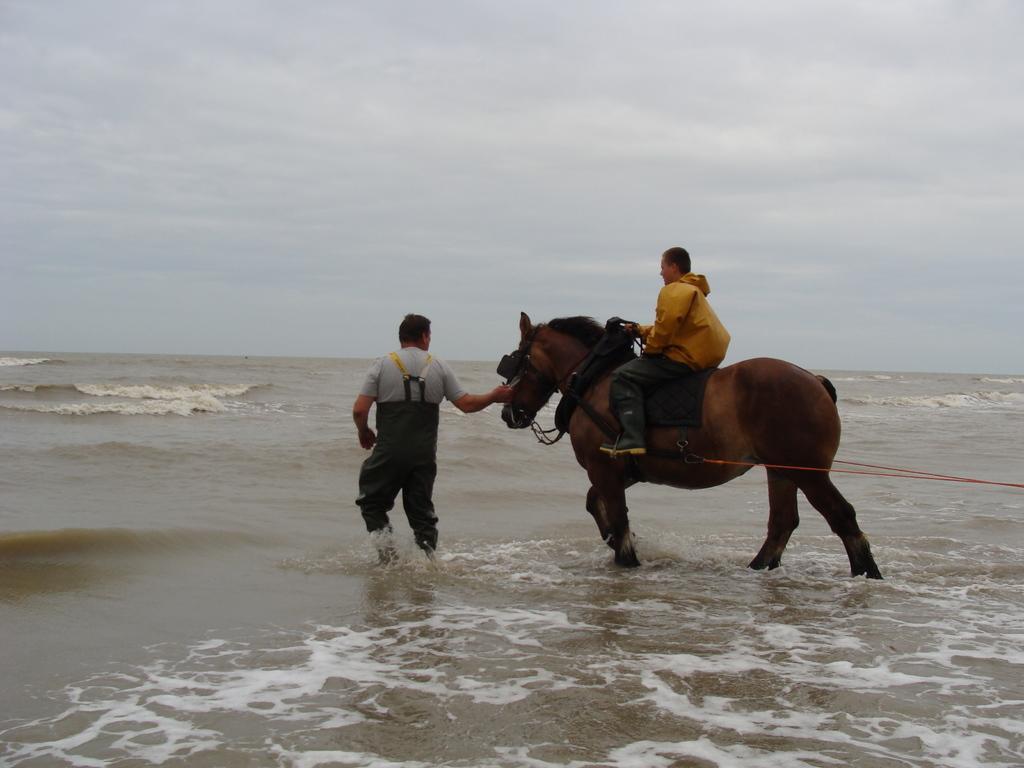Could you give a brief overview of what you see in this image? In this picture we can see a man who is sitting on the horse. Here we can see a one more person who is standing in the water. On the background there is a sky. 